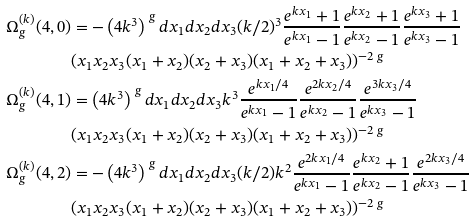<formula> <loc_0><loc_0><loc_500><loc_500>\Omega ^ { ( k ) } _ { g } ( 4 , 0 ) & = - \left ( 4 k ^ { 3 } \right ) ^ { \ g } d x _ { 1 } d x _ { 2 } d x _ { 3 } ( k / 2 ) ^ { 3 } \frac { e ^ { k x _ { 1 } } + 1 } { e ^ { k x _ { 1 } } - 1 } \frac { e ^ { k x _ { 2 } } + 1 } { e ^ { k x _ { 2 } } - 1 } \frac { e ^ { k x _ { 3 } } + 1 } { e ^ { k x _ { 3 } } - 1 } \\ & ( x _ { 1 } x _ { 2 } x _ { 3 } ( x _ { 1 } + x _ { 2 } ) ( x _ { 2 } + x _ { 3 } ) ( x _ { 1 } + x _ { 2 } + x _ { 3 } ) ) ^ { - 2 \ g } \\ \Omega ^ { ( k ) } _ { g } ( 4 , 1 ) & = \left ( 4 k ^ { 3 } \right ) ^ { \ g } d x _ { 1 } d x _ { 2 } d x _ { 3 } k ^ { 3 } \frac { e ^ { k x _ { 1 } / 4 } } { e ^ { k x _ { 1 } } - 1 } \frac { e ^ { 2 k x _ { 2 } / 4 } } { e ^ { k x _ { 2 } } - 1 } \frac { e ^ { 3 k x _ { 3 } / 4 } } { e ^ { k x _ { 3 } } - 1 } \\ & ( x _ { 1 } x _ { 2 } x _ { 3 } ( x _ { 1 } + x _ { 2 } ) ( x _ { 2 } + x _ { 3 } ) ( x _ { 1 } + x _ { 2 } + x _ { 3 } ) ) ^ { - 2 \ g } \\ \Omega ^ { ( k ) } _ { g } ( 4 , 2 ) & = - \left ( 4 k ^ { 3 } \right ) ^ { \ g } d x _ { 1 } d x _ { 2 } d x _ { 3 } ( k / 2 ) k ^ { 2 } \frac { e ^ { 2 k x _ { 1 } / 4 } } { e ^ { k x _ { 1 } } - 1 } \frac { e ^ { k x _ { 2 } } + 1 } { e ^ { k x _ { 2 } } - 1 } \frac { e ^ { 2 k x _ { 3 } / 4 } } { e ^ { k x _ { 3 } } - 1 } \\ & ( x _ { 1 } x _ { 2 } x _ { 3 } ( x _ { 1 } + x _ { 2 } ) ( x _ { 2 } + x _ { 3 } ) ( x _ { 1 } + x _ { 2 } + x _ { 3 } ) ) ^ { - 2 \ g }</formula> 